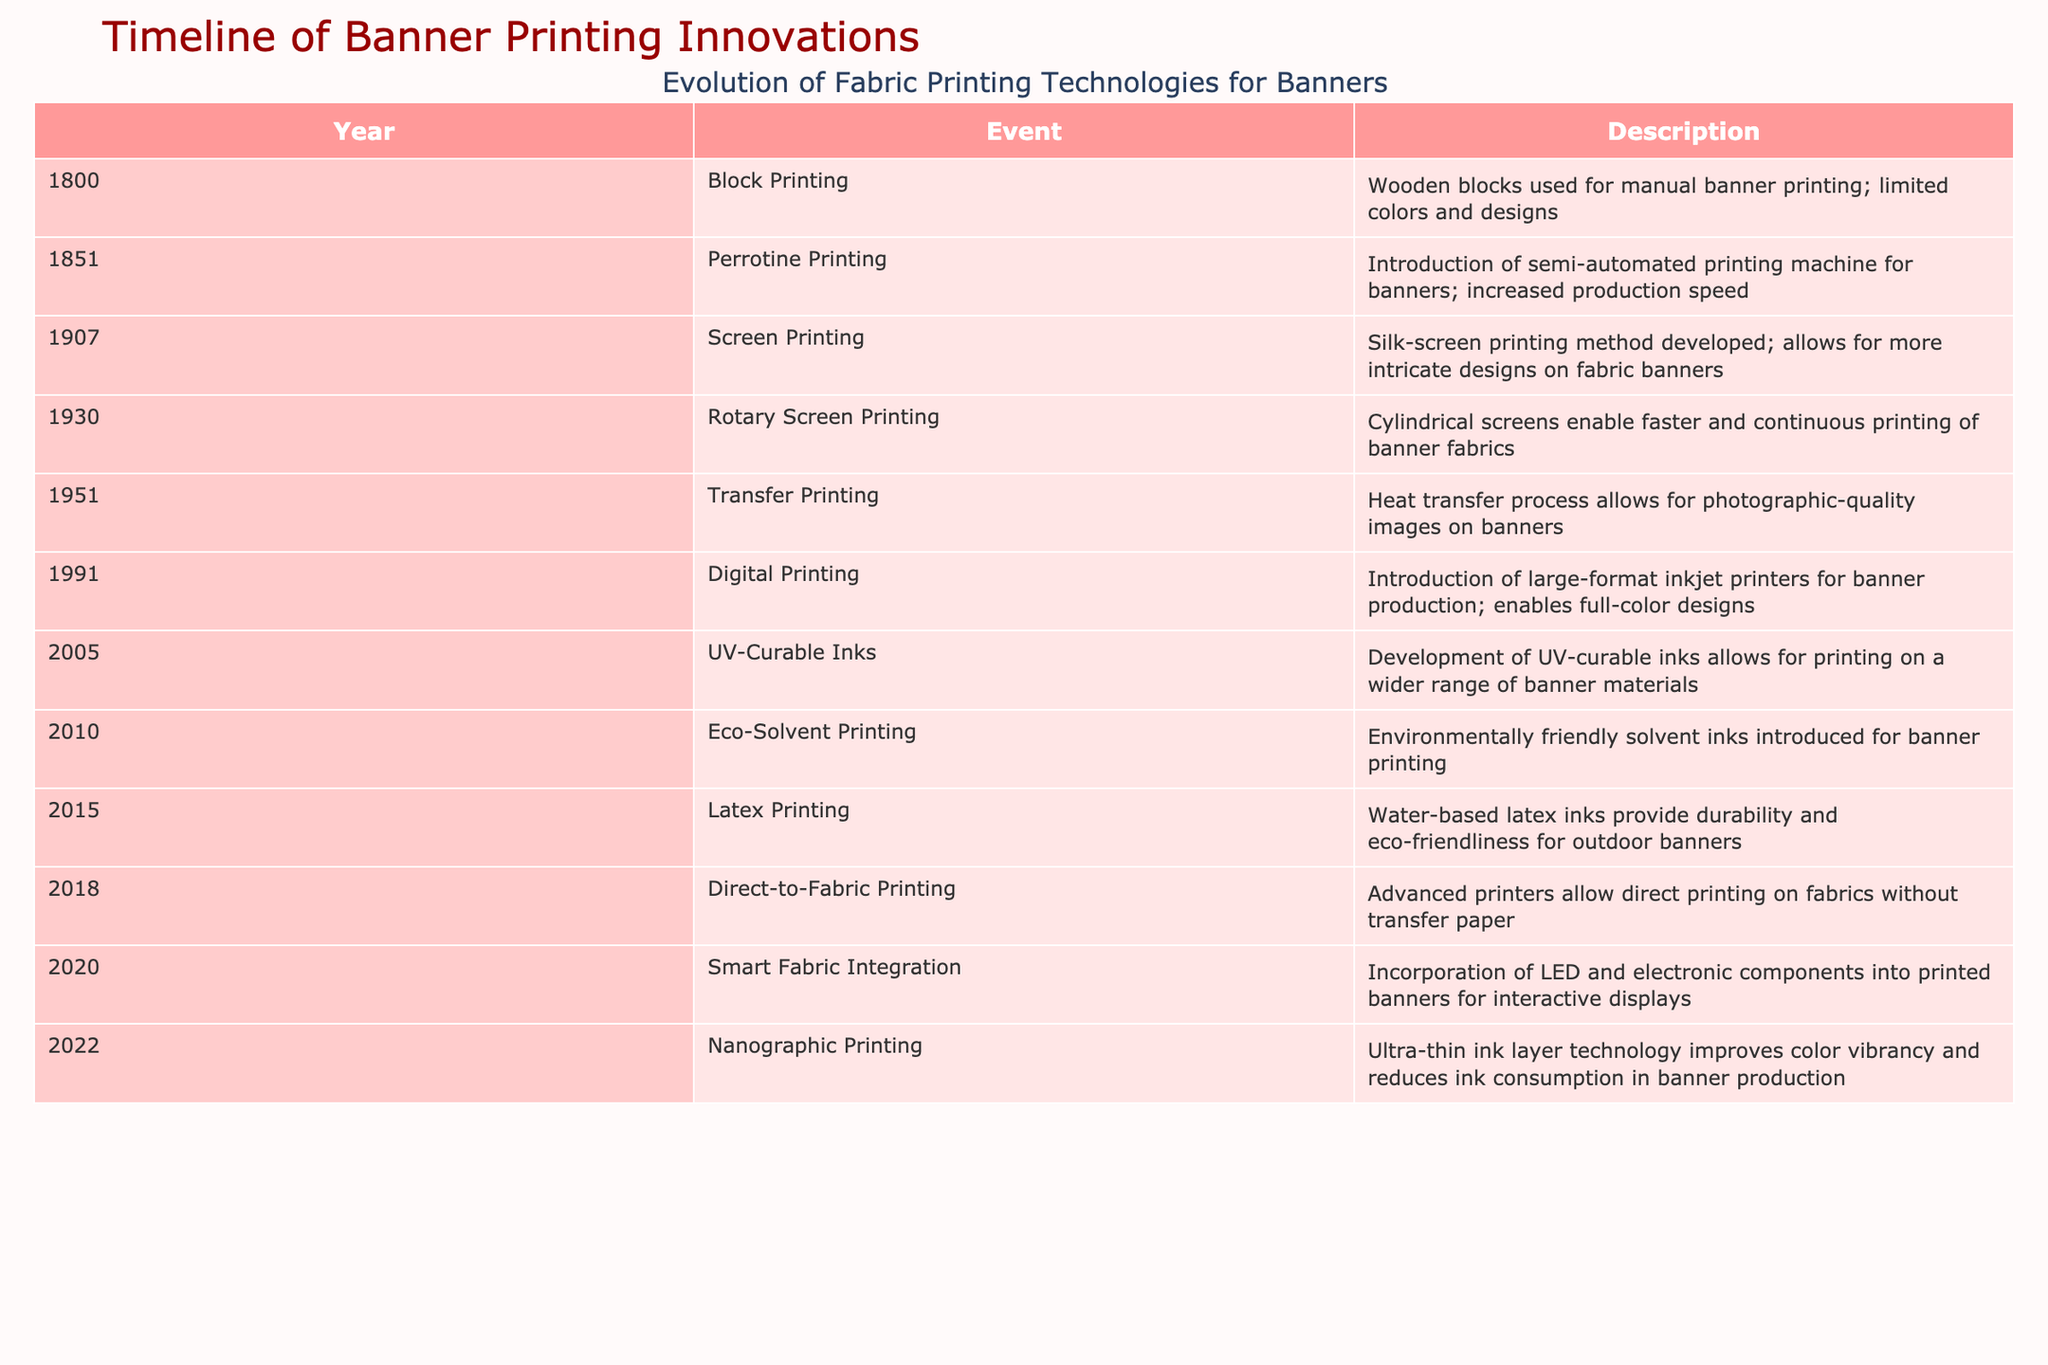What year did digital printing technology for banners first appear? According to the table, digital printing was introduced in 1991. I can find this by checking the "Year" column for the entry that mentions "Digital Printing."
Answer: 1991 What technology was used for printing before screen printing? The table indicates that block printing was the technology used before screen printing, which was developed in 1907. I find this by looking for the year before screen printing in the "Year" column.
Answer: Block Printing Which printing technology allows for the fastest continuous printing of banner fabrics? According to the table, rotary screen printing, introduced in 1930, enables faster and continuous printing. I locate the row for rotary screen printing and reference its description.
Answer: Rotary Screen Printing Is eco-solvent printing more environmentally friendly compared to previous printing technologies? Yes, eco-solvent printing, introduced in 2010, specifically states that it features environmentally friendly solvent inks. I can verify this directly from the description in the table for that entry.
Answer: Yes What are the main advancements in banner printing technologies from 1991 to 2022? The advancements include digital printing in 1991, UV-curable inks in 2005, eco-solvent printing in 2010, latex printing in 2015, direct-to-fabric printing in 2018, smart fabric integration in 2020, and nanographic printing in 2022. I consolidate this by listing technologies within those years based on the table.
Answer: Digital, UV-Curable, Eco-Solvent, Latex, Direct-to-Fabric, Smart Fabric, Nanographic What is the difference in years between the introduction of transfer printing and latex printing? Transfer printing was introduced in 1951, and latex printing was introduced in 2015. To find the difference, I subtract 1951 from 2015, resulting in 64 years.
Answer: 64 years Which fabric printing technology allows for the incorporation of electronic components? The table shows that smart fabric integration, introduced in 2020, allows for the inclusion of LED and electronic components. I find this by checking the event description for the year 2020 in the table.
Answer: Smart Fabric Integration How many years passed between the introduction of screen printing and direct-to-fabric printing? Screen printing was developed in 1907 and direct-to-fabric printing was introduced in 2018. I calculate the time difference by subtracting 1907 from 2018, which gives me 111 years.
Answer: 111 years Did the introduction of nanographic printing improve color vibrancy in banners? Yes, the description states that nanographic printing improves color vibrancy, among other benefits. I can check the row for nanographic printing for confirmation.
Answer: Yes 